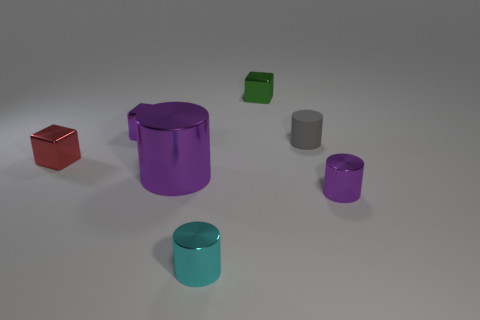Subtract 1 cylinders. How many cylinders are left? 3 Add 1 cyan shiny cubes. How many objects exist? 8 Subtract all cylinders. How many objects are left? 3 Subtract all large purple shiny cylinders. Subtract all big blue matte cylinders. How many objects are left? 6 Add 1 small green shiny things. How many small green shiny things are left? 2 Add 4 cyan things. How many cyan things exist? 5 Subtract 1 red cubes. How many objects are left? 6 